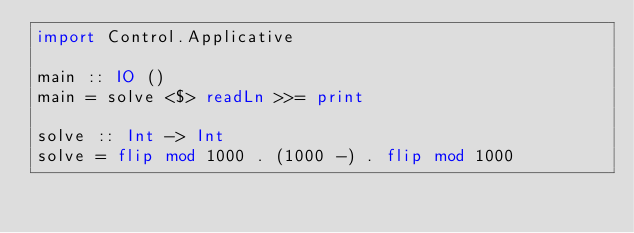Convert code to text. <code><loc_0><loc_0><loc_500><loc_500><_Haskell_>import Control.Applicative

main :: IO ()
main = solve <$> readLn >>= print

solve :: Int -> Int
solve = flip mod 1000 . (1000 -) . flip mod 1000
</code> 